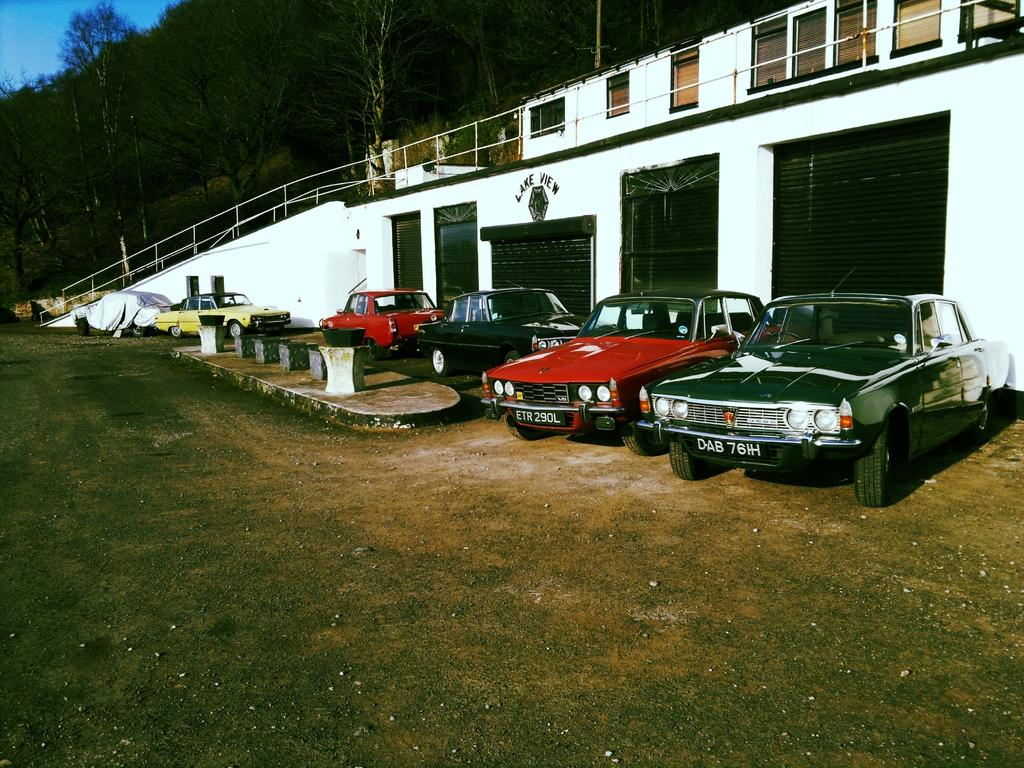What types of objects can be seen in the image? There are vehicles and houses in the image. What architectural features are present in the image? There are windows, shutters, and railing in the image. What type of vegetation is visible in the image? There are trees in the image. What is the color of the sky in the image? The sky is blue in color. Can you tell me how many roses are in the image? There are no roses present in the image. What type of lumber is being used to construct the houses in the image? The image does not provide information about the type of lumber used to construct the houses. 